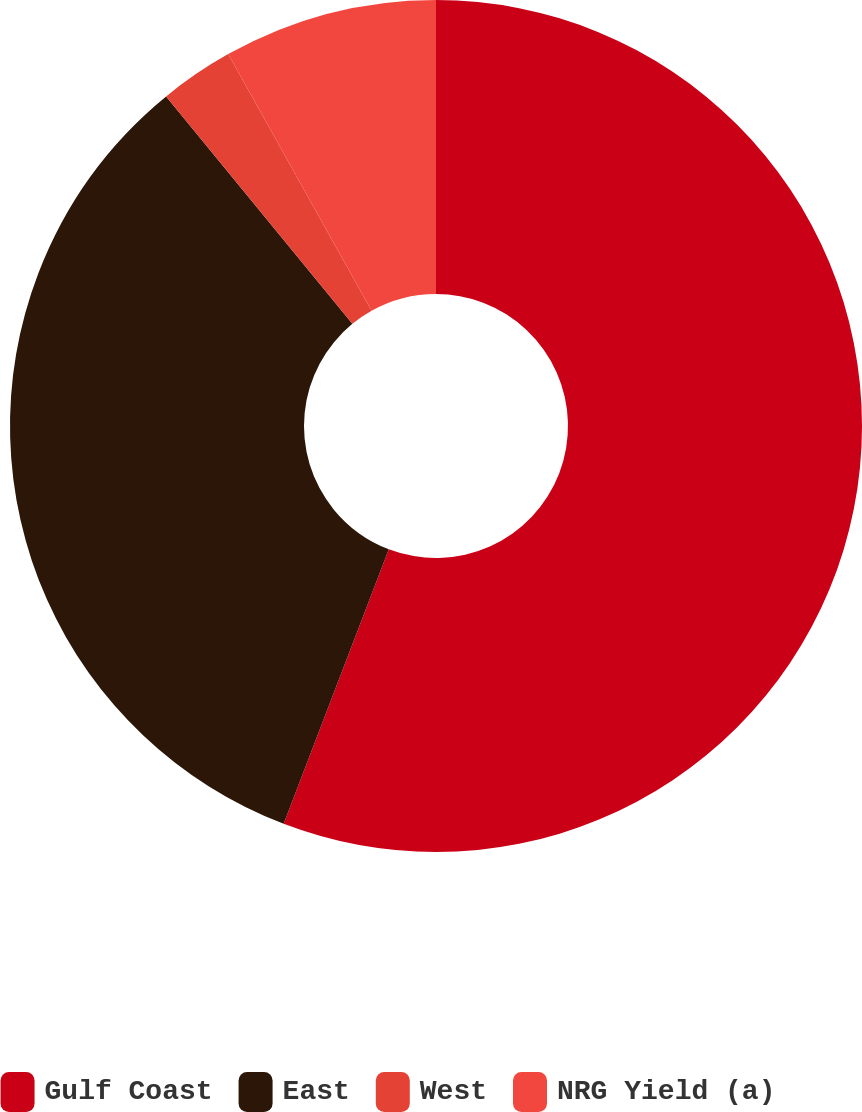Convert chart to OTSL. <chart><loc_0><loc_0><loc_500><loc_500><pie_chart><fcel>Gulf Coast<fcel>East<fcel>West<fcel>NRG Yield (a)<nl><fcel>55.82%<fcel>33.26%<fcel>2.81%<fcel>8.11%<nl></chart> 